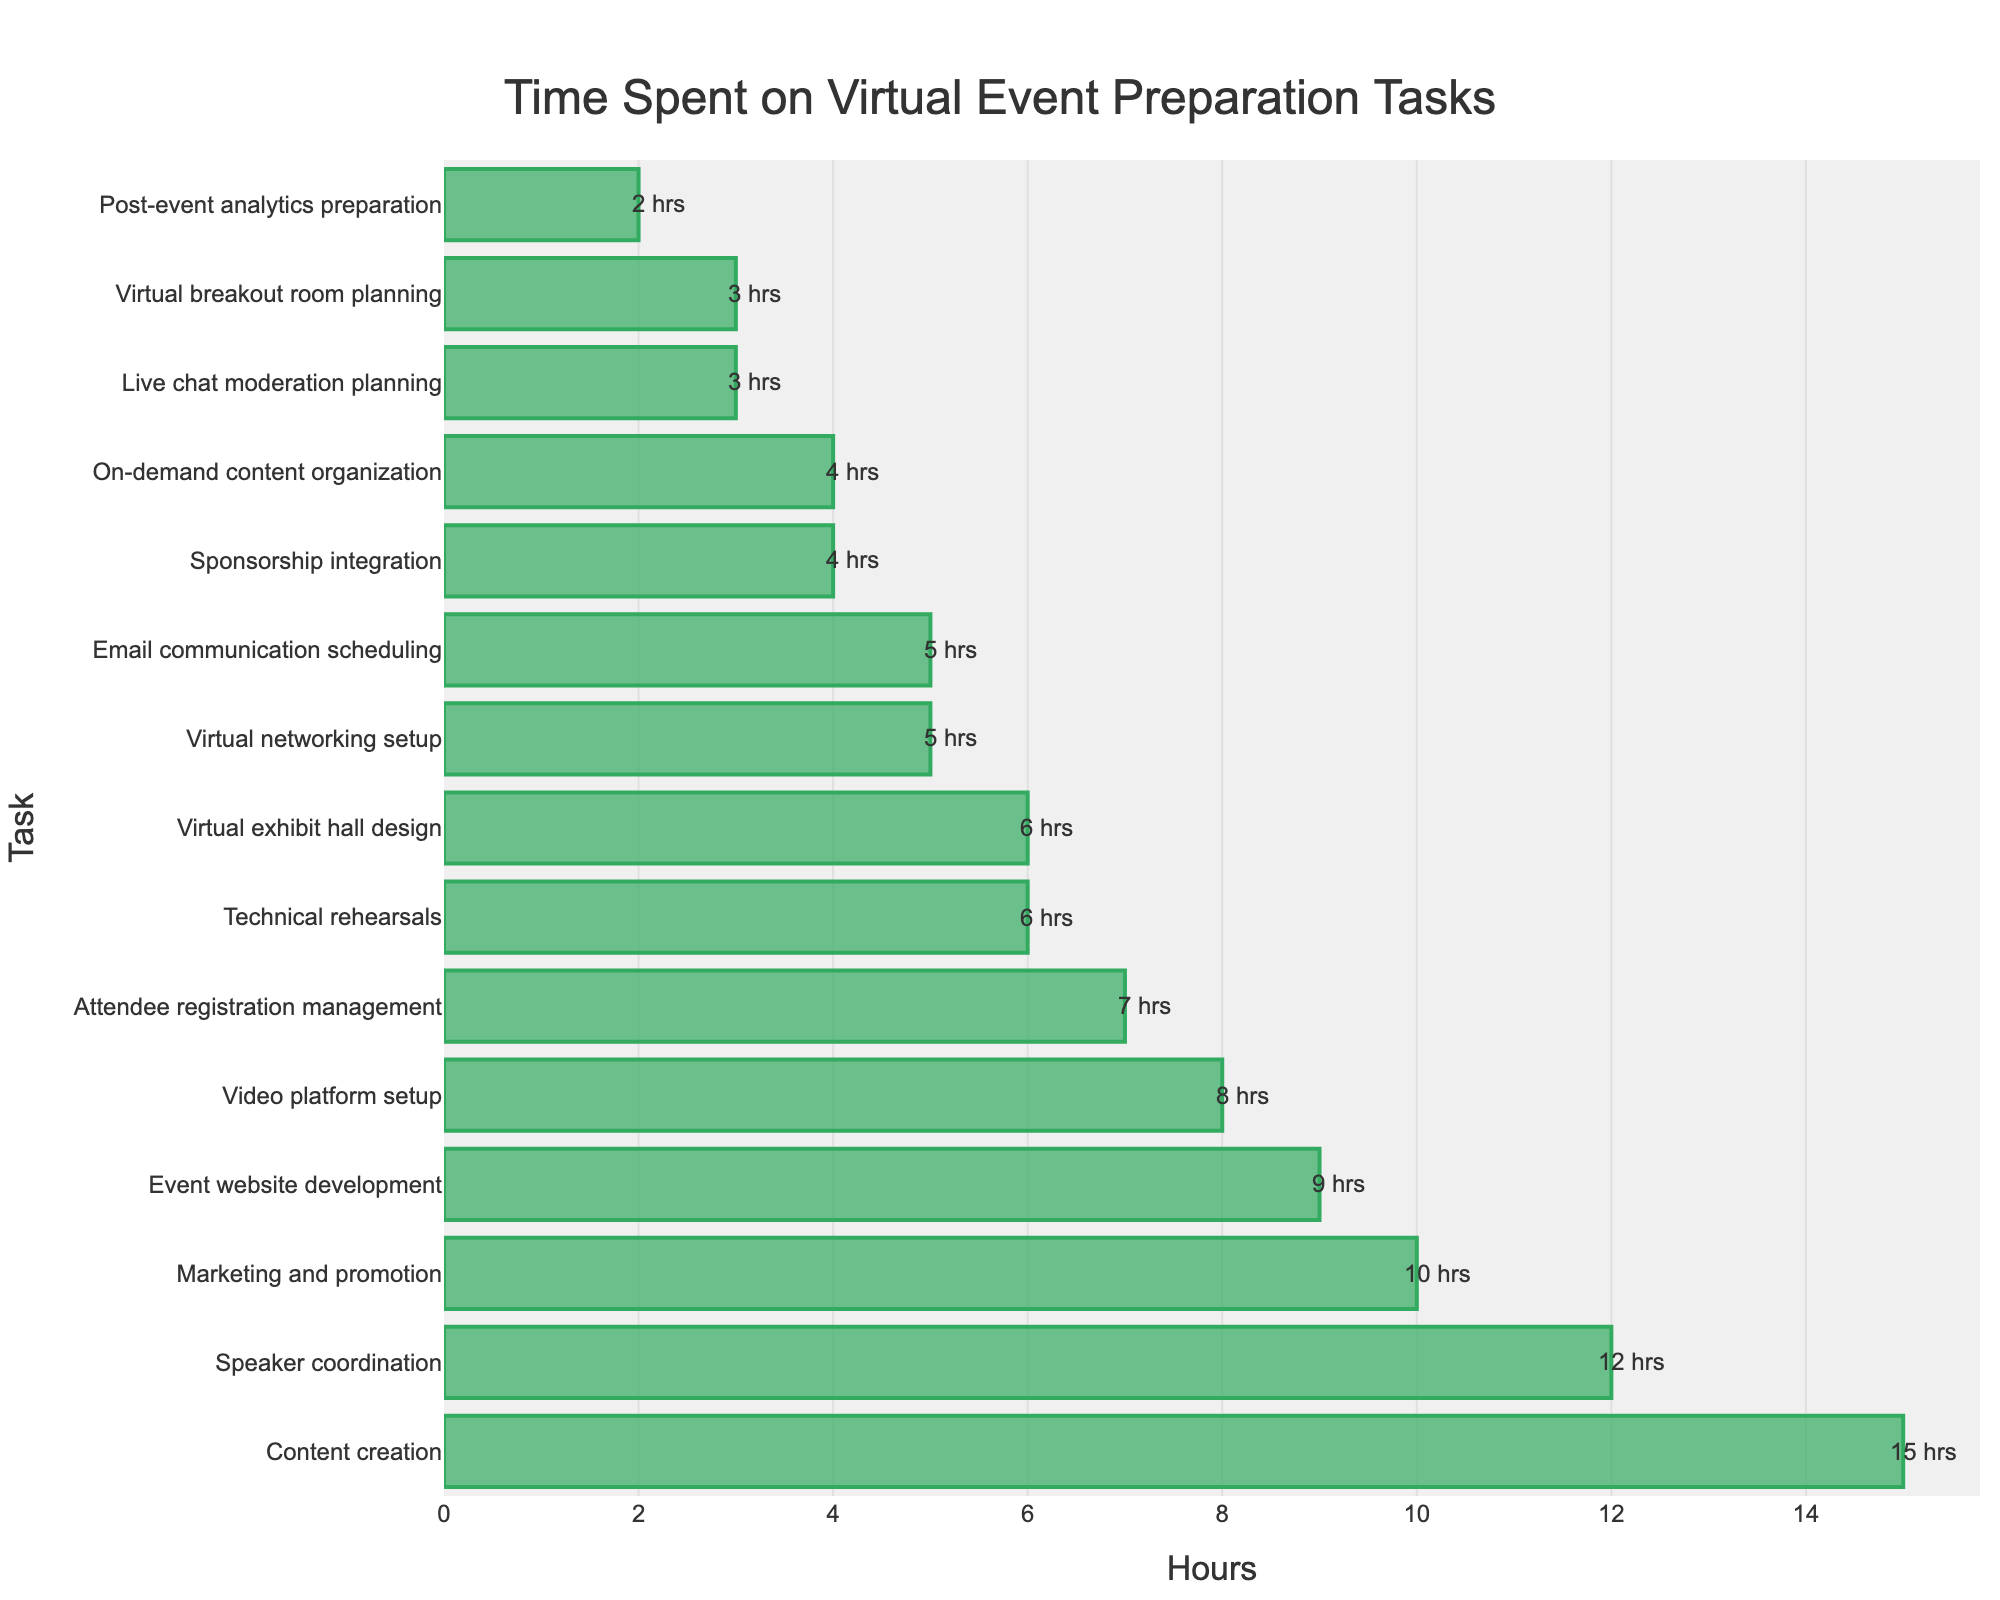What are the top two tasks event planners spend the most time on? To find the top two tasks, look at the two tallest bars in the figure. The two tallest bars represent "Content creation" (15 hours) and "Speaker coordination" (12 hours)
Answer: Content creation and Speaker coordination How many more hours are spent on 'Content creation' than 'Virtual exhibit hall design'? Find the hours for both tasks from the bars, with "Content creation" at 15 hours and "Virtual exhibit hall design" at 6 hours. Subtract 6 from 15 to get the difference
Answer: 9 hours What is the total time spent on 'Marketing and promotion' and 'Email communication scheduling'? Sum the hours spent on each task. From the figure, "Marketing and promotion" is 10 hours and "Email communication scheduling" is 5 hours. Adding them gives 10 + 5 = 15 hours
Answer: 15 hours Which task takes less time: 'Attendee registration management' or 'Sponsorship integration'? Compare the lengths of the bars for "Attendee registration management" (7 hours) and "Sponsorship integration" (4 hours). The shorter bar belongs to "Sponsorship integration"
Answer: Sponsorship integration What is the average time spent on 'Technical rehearsals', 'Live chat moderation planning', and 'Post-event analytics preparation'? Find the hours for each task: "Technical rehearsals" (6 hours), "Live chat moderation planning" (3 hours), and "Post-event analytics preparation" (2 hours). Sum them up 6 + 3 + 2 = 11 hours and divide by the number of tasks (3). The average is 11/3 ≈ 3.67 hours
Answer: 3.67 hours Is the time spent on 'Virtual networking setup' more than the time spent on 'Sponsorship integration'? Compare the hours for each task: "Virtual networking setup" (5 hours) and "Sponsorship integration" (4 hours). The bar for "Virtual networking setup" is longer
Answer: Yes Which task do event planners spend less than 5 hours on? Identify tasks with bars representing less than 5 hours. These are "Sponsorship integration" (4 hours), "Live chat moderation planning" (3 hours), "Post-event analytics preparation" (2 hours), and "Virtual breakout room planning" (3 hours)
Answer: Sponsorship integration, Live chat moderation planning, Post-event analytics preparation, and Virtual breakout room planning What is the total time spent on 'Event website development', 'Attendee registration management', and 'Video platform setup'? Sum the hours for the tasks: "Event website development" (9 hours), "Attendee registration management" (7 hours), and "Video platform setup" (8 hours). The total is 9 + 7 + 8 = 24 hours
Answer: 24 hours How many tasks require at least 10 hours of work? Identify tasks with bars equal to or greater than 10 hours: "Content creation" (15 hours), "Speaker coordination" (12 hours), and "Marketing and promotion" (10 hours). There are three such tasks
Answer: 3 tasks Which takes more time: 'On-demand content organization' or 'Virtual breakout room planning'? Compare the hours for each task: "On-demand content organization" (4 hours) and "Virtual breakout room planning" (3 hours). The longer bar is for "On-demand content organization"
Answer: On-demand content organization 